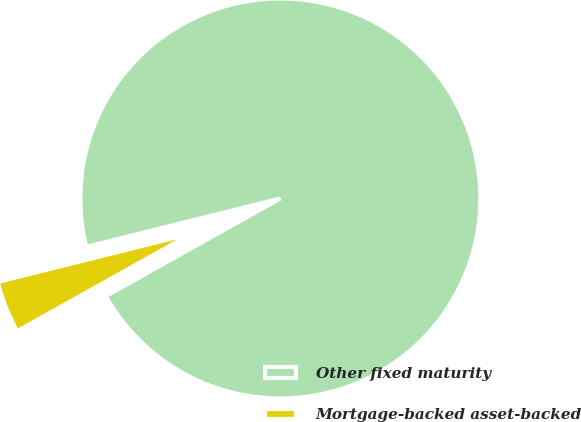Convert chart to OTSL. <chart><loc_0><loc_0><loc_500><loc_500><pie_chart><fcel>Other fixed maturity<fcel>Mortgage-backed asset-backed<nl><fcel>95.78%<fcel>4.22%<nl></chart> 